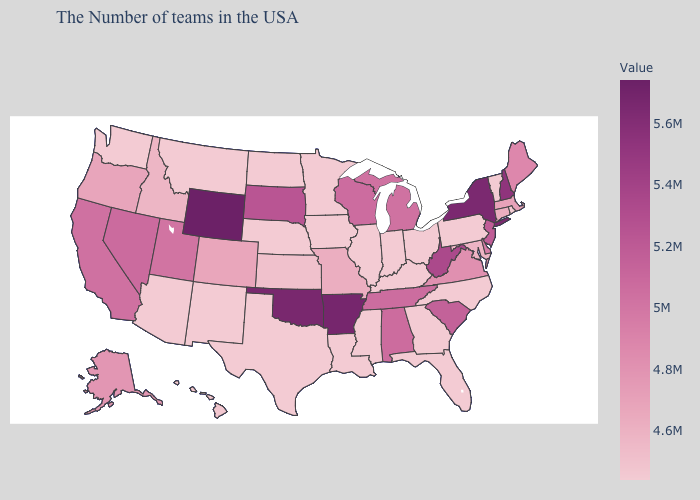Does Iowa have the lowest value in the USA?
Write a very short answer. Yes. Does Massachusetts have the highest value in the Northeast?
Keep it brief. No. Which states have the lowest value in the South?
Be succinct. North Carolina, Florida, Georgia, Kentucky, Mississippi, Louisiana, Texas. Among the states that border Wyoming , which have the lowest value?
Keep it brief. Nebraska, Montana. Does Maine have a lower value than Texas?
Short answer required. No. Does Wyoming have the highest value in the USA?
Be succinct. Yes. Among the states that border Oregon , does Washington have the lowest value?
Quick response, please. Yes. 